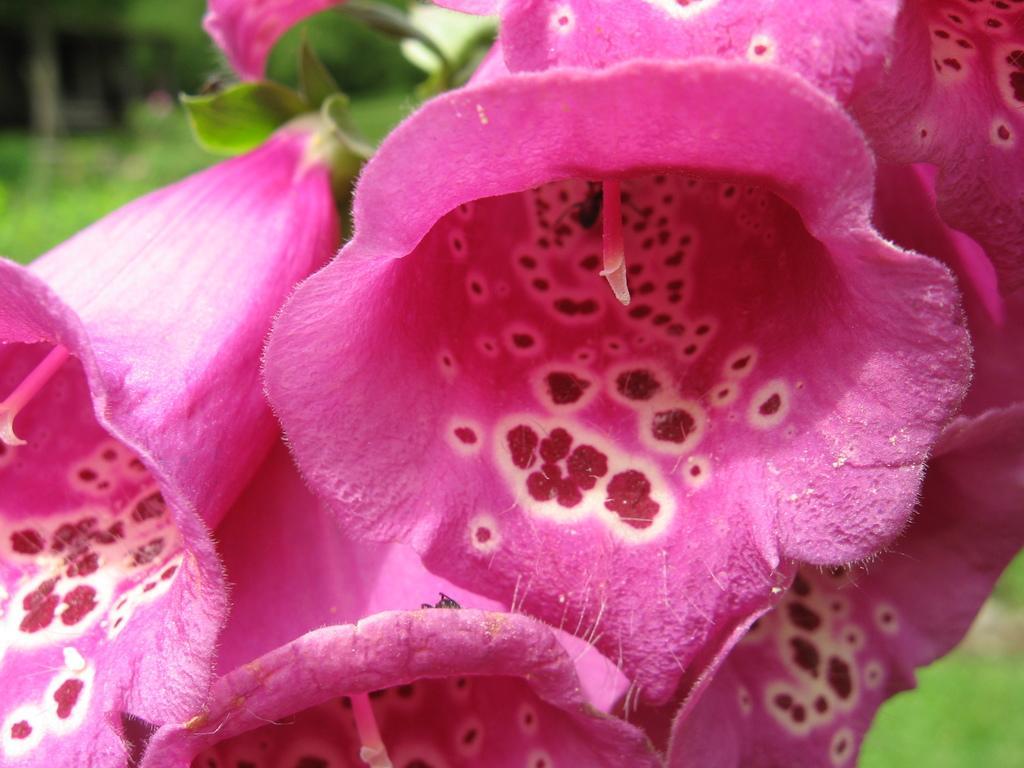Please provide a concise description of this image. In this picture I can see pink flowers, and there is blur background. 